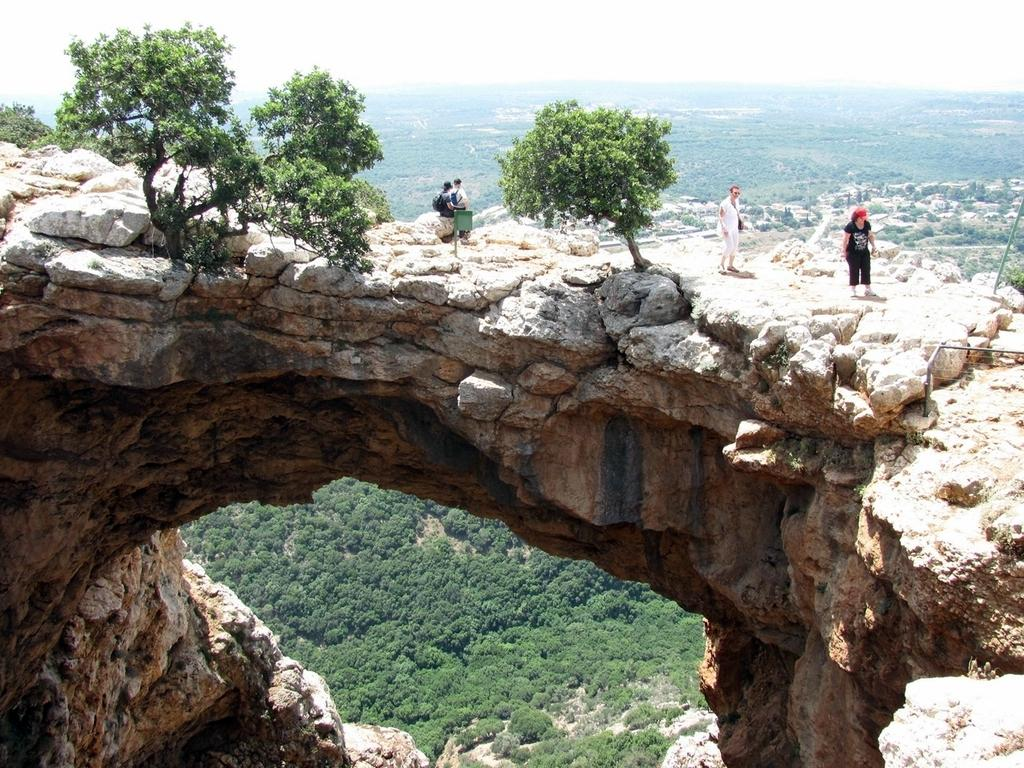Who or what can be seen in the image? There are people in the image. What type of natural elements are present in the image? There are trees in the image. What color and objects are present in the front of the image? There are green color things in the front of the image. What color and objects are present in the background of the image? There are green color things in the background of the image. What type of hole can be seen in the image? There is no hole present in the image. Whose birthday is being celebrated in the image? There is no indication of a birthday celebration in the image. 